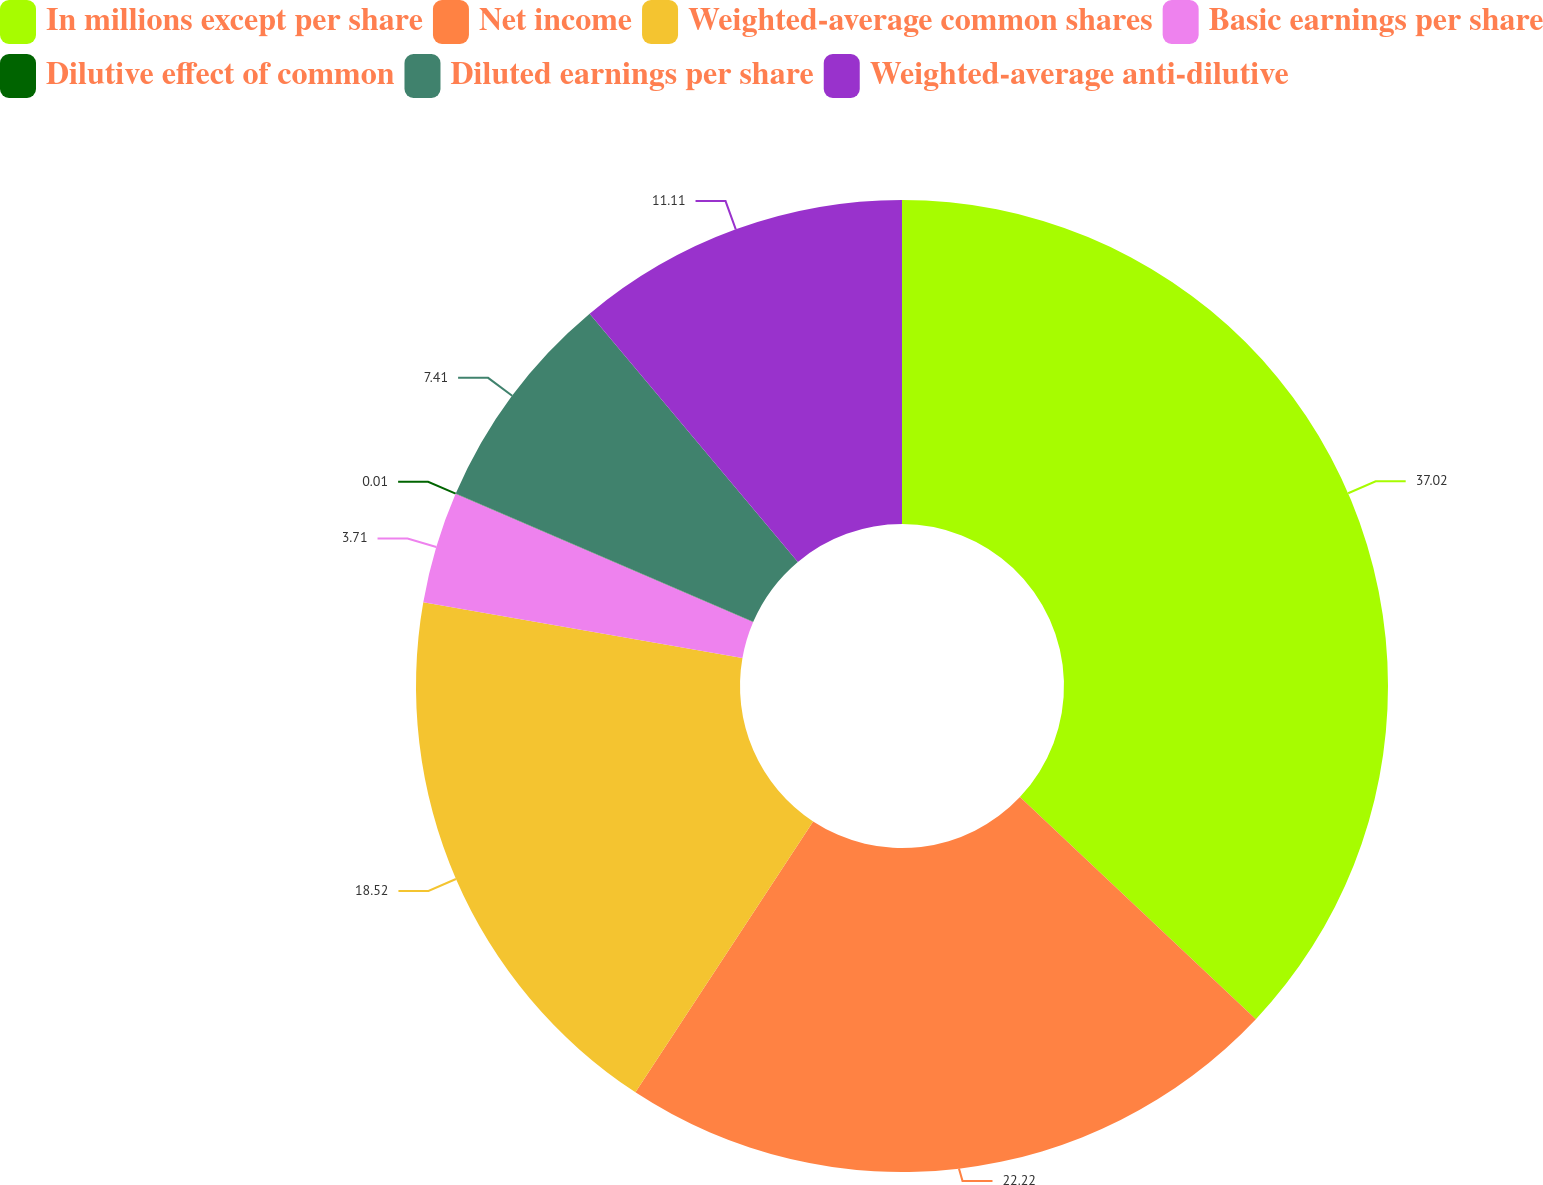Convert chart. <chart><loc_0><loc_0><loc_500><loc_500><pie_chart><fcel>In millions except per share<fcel>Net income<fcel>Weighted-average common shares<fcel>Basic earnings per share<fcel>Dilutive effect of common<fcel>Diluted earnings per share<fcel>Weighted-average anti-dilutive<nl><fcel>37.02%<fcel>22.22%<fcel>18.52%<fcel>3.71%<fcel>0.01%<fcel>7.41%<fcel>11.11%<nl></chart> 